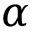<formula> <loc_0><loc_0><loc_500><loc_500>\alpha</formula> 